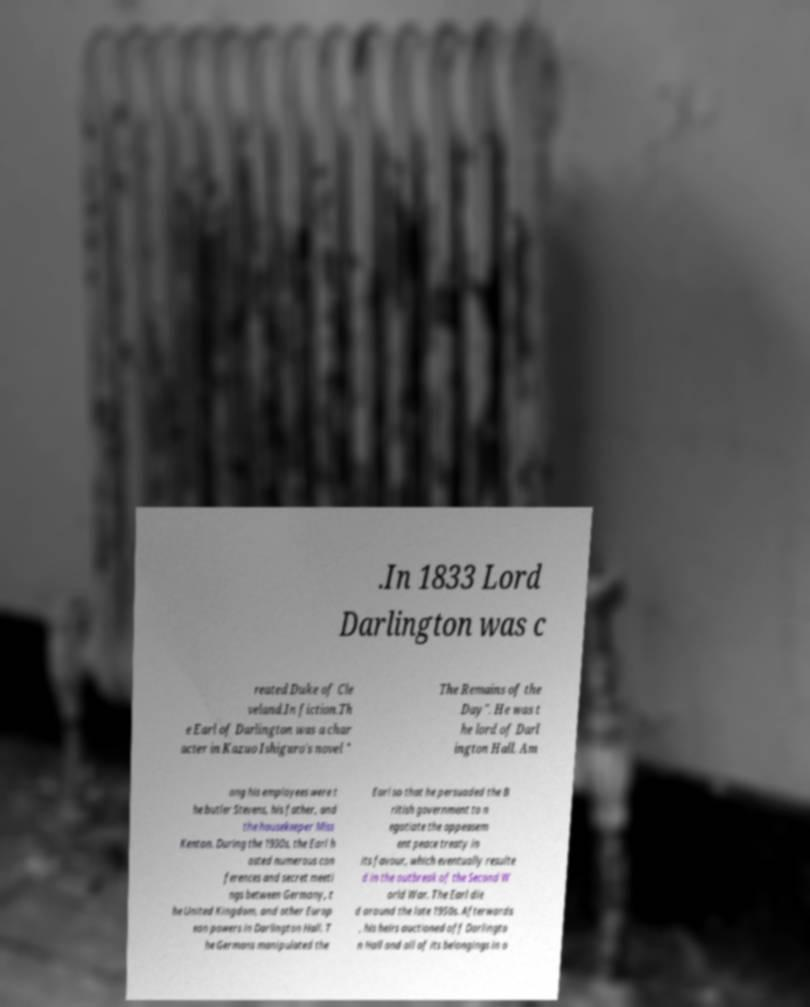Can you read and provide the text displayed in the image?This photo seems to have some interesting text. Can you extract and type it out for me? .In 1833 Lord Darlington was c reated Duke of Cle veland.In fiction.Th e Earl of Darlington was a char acter in Kazuo Ishiguro's novel " The Remains of the Day". He was t he lord of Darl ington Hall. Am ong his employees were t he butler Stevens, his father, and the housekeeper Miss Kenton. During the 1930s, the Earl h osted numerous con ferences and secret meeti ngs between Germany, t he United Kingdom, and other Europ ean powers in Darlington Hall. T he Germans manipulated the Earl so that he persuaded the B ritish government to n egotiate the appeasem ent peace treaty in its favour, which eventually resulte d in the outbreak of the Second W orld War. The Earl die d around the late 1950s. Afterwards , his heirs auctioned off Darlingto n Hall and all of its belongings in o 